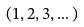<formula> <loc_0><loc_0><loc_500><loc_500>( 1 , 2 , 3 , \dots )</formula> 